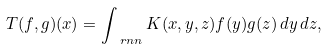<formula> <loc_0><loc_0><loc_500><loc_500>T ( f , g ) ( x ) = \int _ { \ r n n } K ( x , y , z ) f ( y ) g ( z ) \, d y \, d z ,</formula> 